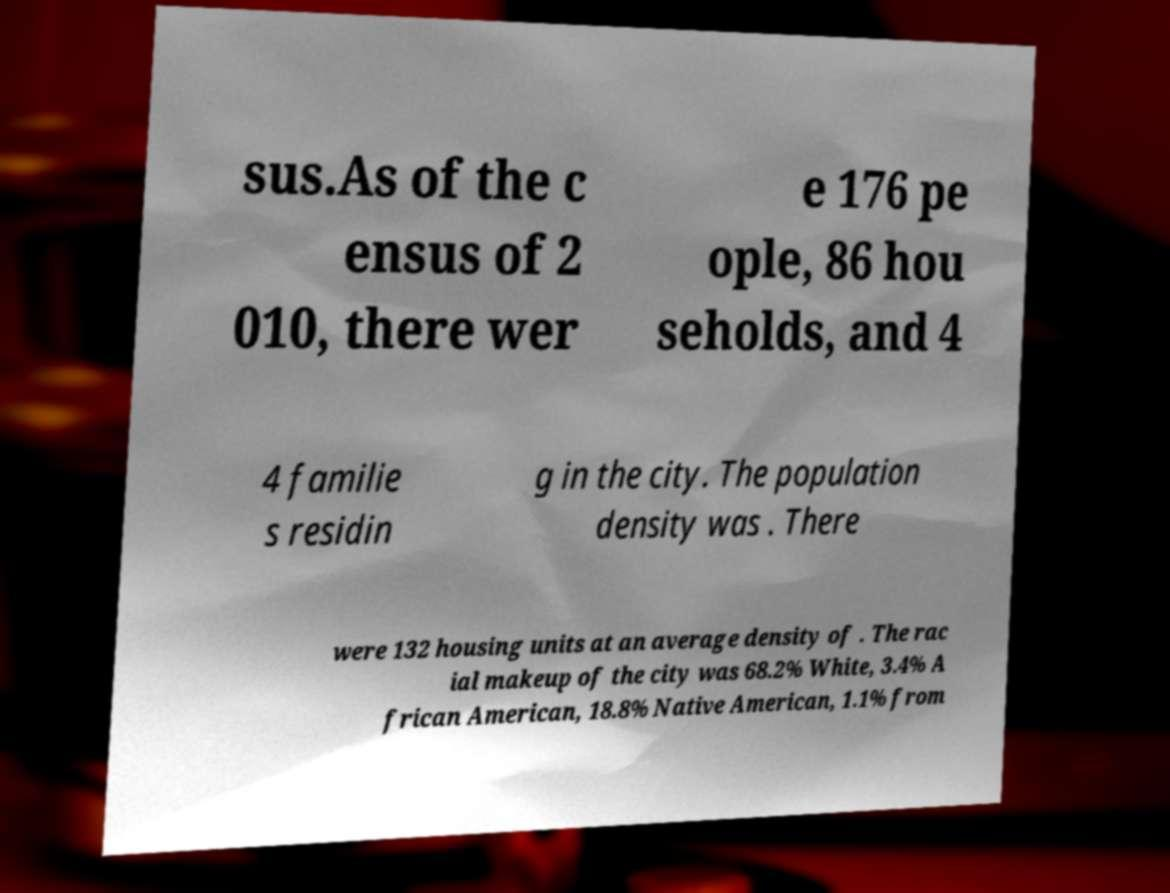Please identify and transcribe the text found in this image. sus.As of the c ensus of 2 010, there wer e 176 pe ople, 86 hou seholds, and 4 4 familie s residin g in the city. The population density was . There were 132 housing units at an average density of . The rac ial makeup of the city was 68.2% White, 3.4% A frican American, 18.8% Native American, 1.1% from 